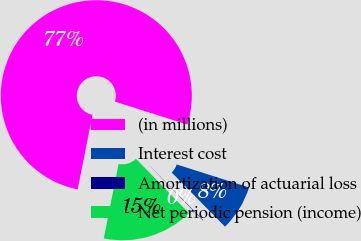<chart> <loc_0><loc_0><loc_500><loc_500><pie_chart><fcel>(in millions)<fcel>Interest cost<fcel>Amortization of actuarial loss<fcel>Net periodic pension (income)<nl><fcel>76.76%<fcel>7.75%<fcel>0.08%<fcel>15.41%<nl></chart> 